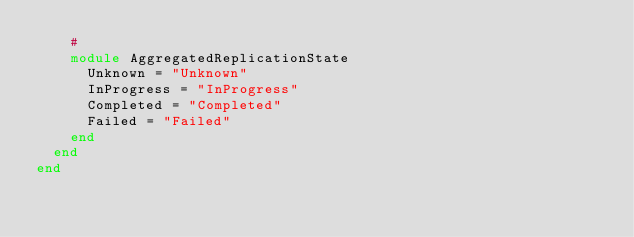Convert code to text. <code><loc_0><loc_0><loc_500><loc_500><_Ruby_>    #
    module AggregatedReplicationState
      Unknown = "Unknown"
      InProgress = "InProgress"
      Completed = "Completed"
      Failed = "Failed"
    end
  end
end
</code> 